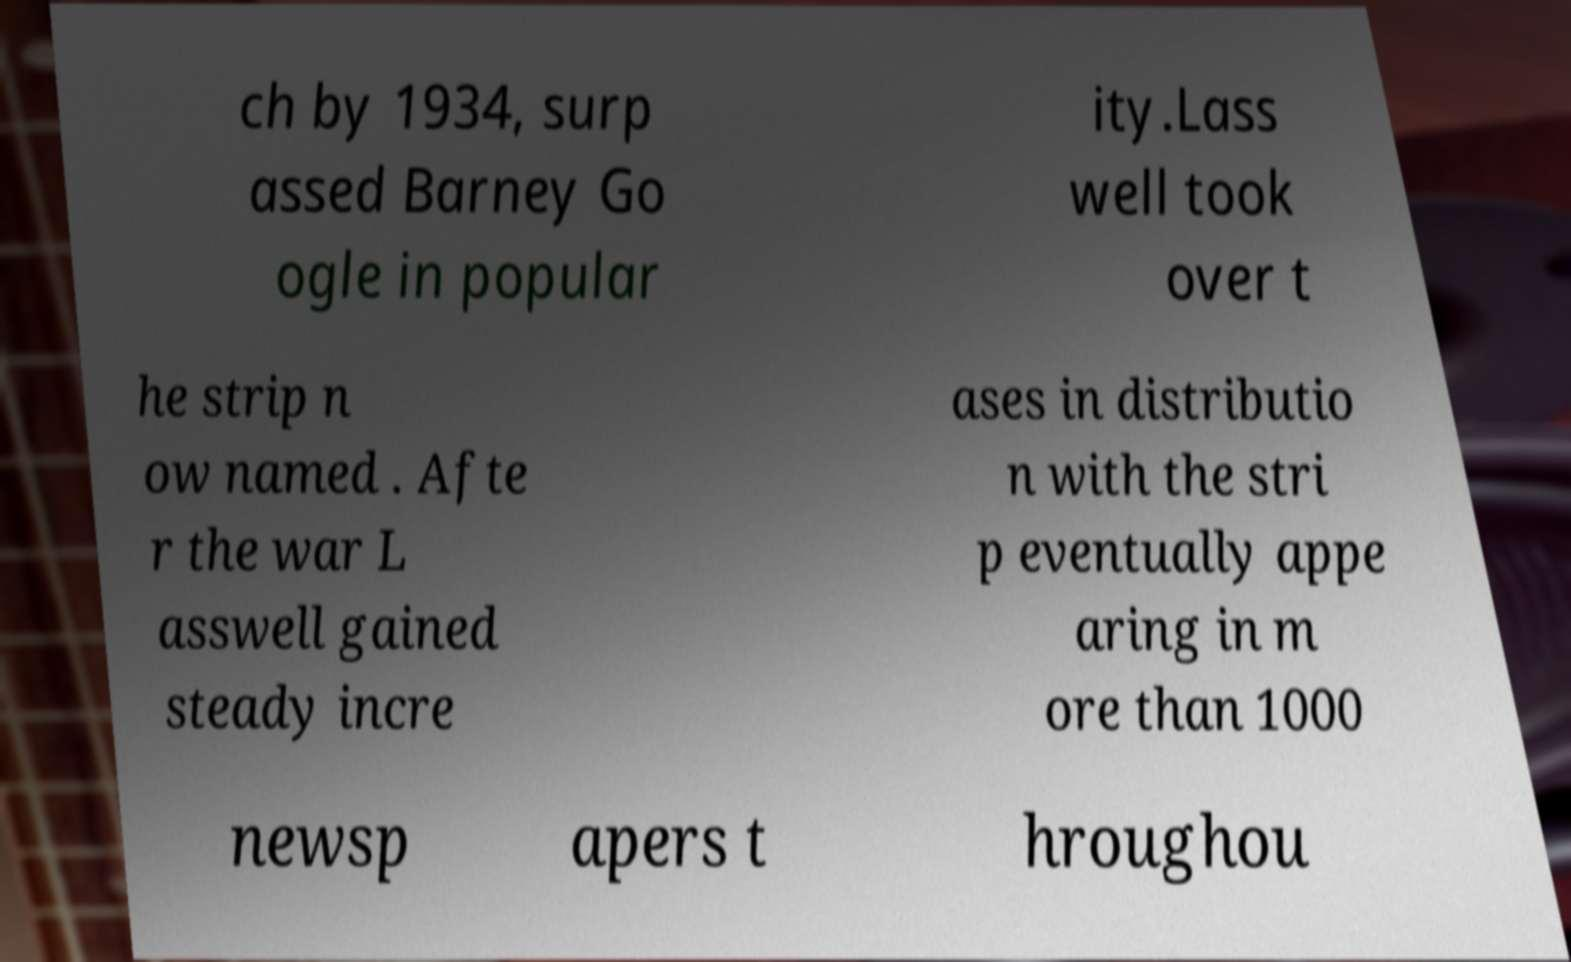I need the written content from this picture converted into text. Can you do that? ch by 1934, surp assed Barney Go ogle in popular ity.Lass well took over t he strip n ow named . Afte r the war L asswell gained steady incre ases in distributio n with the stri p eventually appe aring in m ore than 1000 newsp apers t hroughou 